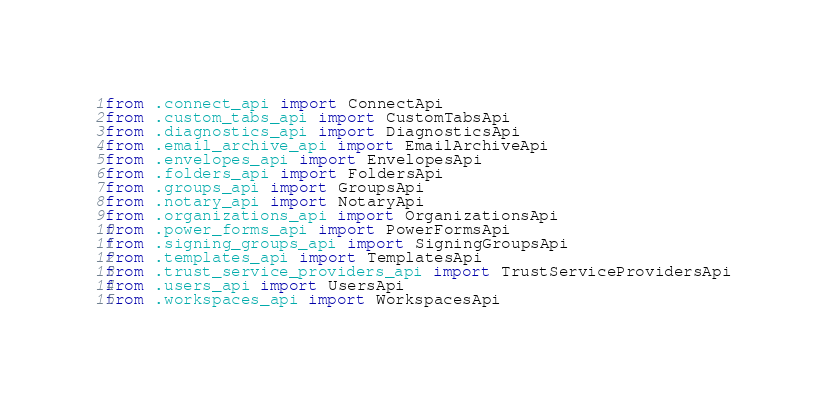Convert code to text. <code><loc_0><loc_0><loc_500><loc_500><_Python_>from .connect_api import ConnectApi
from .custom_tabs_api import CustomTabsApi
from .diagnostics_api import DiagnosticsApi
from .email_archive_api import EmailArchiveApi
from .envelopes_api import EnvelopesApi
from .folders_api import FoldersApi
from .groups_api import GroupsApi
from .notary_api import NotaryApi
from .organizations_api import OrganizationsApi
from .power_forms_api import PowerFormsApi
from .signing_groups_api import SigningGroupsApi
from .templates_api import TemplatesApi
from .trust_service_providers_api import TrustServiceProvidersApi
from .users_api import UsersApi
from .workspaces_api import WorkspacesApi
</code> 